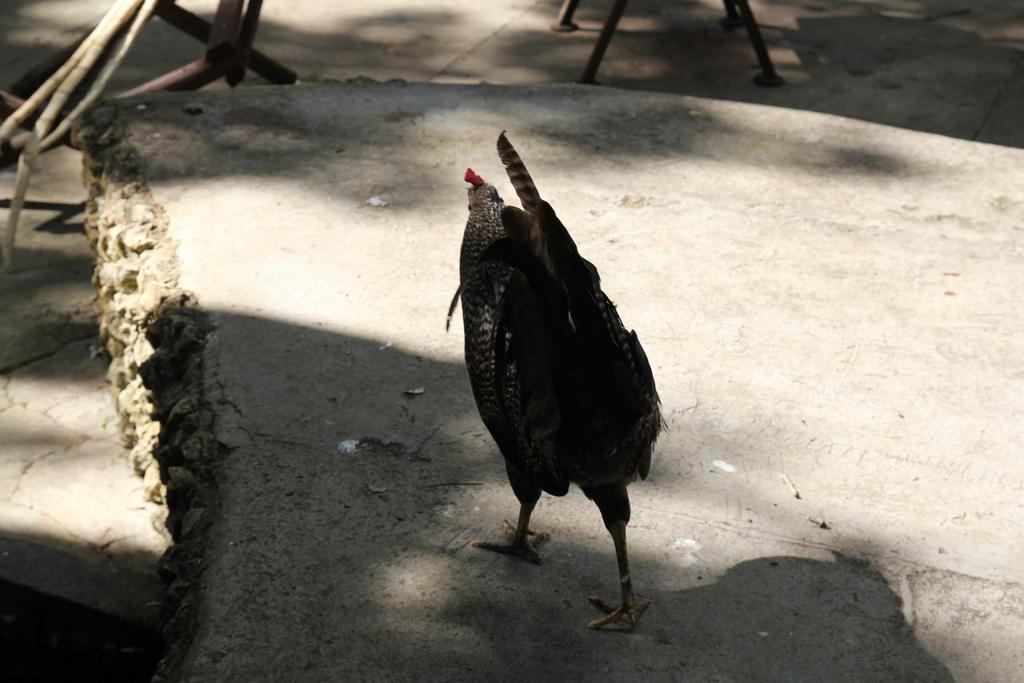What type of animal is in the image? There is a hen in the image. What colors can be seen on the hen? The hen is black and red in color. What type of surface is the hen standing on? The hen is on a concrete surface. What can be seen in the background of the image? There are iron rods visible in the background of the image. Can you see any eggnog being consumed by the hen in the image? There is no eggnog present in the image, and the hen is not consuming anything. How many spiders are crawling on the hen in the image? There are no spiders visible in the image; only the hen and the concrete surface are present. 